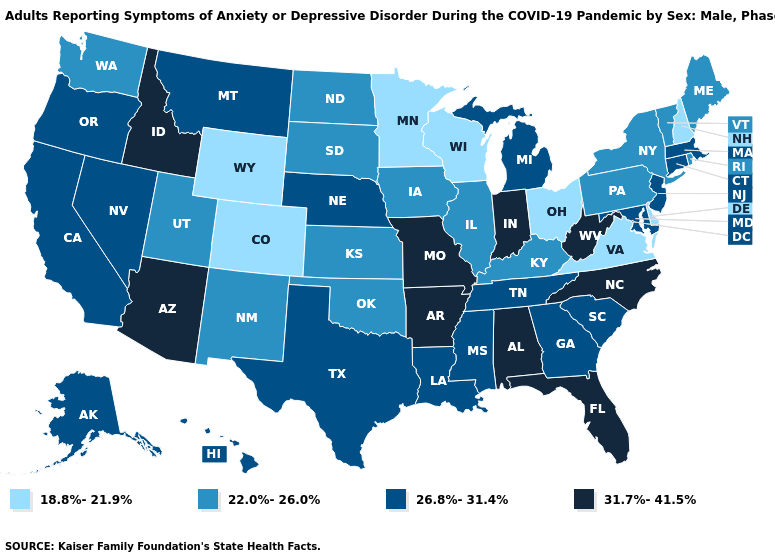Among the states that border Ohio , which have the highest value?
Be succinct. Indiana, West Virginia. What is the lowest value in the USA?
Give a very brief answer. 18.8%-21.9%. Does Nevada have a lower value than Florida?
Short answer required. Yes. Does North Carolina have the highest value in the South?
Write a very short answer. Yes. How many symbols are there in the legend?
Concise answer only. 4. Name the states that have a value in the range 18.8%-21.9%?
Concise answer only. Colorado, Delaware, Minnesota, New Hampshire, Ohio, Virginia, Wisconsin, Wyoming. Among the states that border Iowa , does Missouri have the lowest value?
Keep it brief. No. Does Michigan have a higher value than Ohio?
Quick response, please. Yes. What is the value of Florida?
Give a very brief answer. 31.7%-41.5%. Name the states that have a value in the range 26.8%-31.4%?
Concise answer only. Alaska, California, Connecticut, Georgia, Hawaii, Louisiana, Maryland, Massachusetts, Michigan, Mississippi, Montana, Nebraska, Nevada, New Jersey, Oregon, South Carolina, Tennessee, Texas. Name the states that have a value in the range 22.0%-26.0%?
Quick response, please. Illinois, Iowa, Kansas, Kentucky, Maine, New Mexico, New York, North Dakota, Oklahoma, Pennsylvania, Rhode Island, South Dakota, Utah, Vermont, Washington. Among the states that border Michigan , does Wisconsin have the highest value?
Give a very brief answer. No. Is the legend a continuous bar?
Quick response, please. No. Does Tennessee have a lower value than Iowa?
Concise answer only. No. Among the states that border Nevada , does California have the lowest value?
Be succinct. No. 